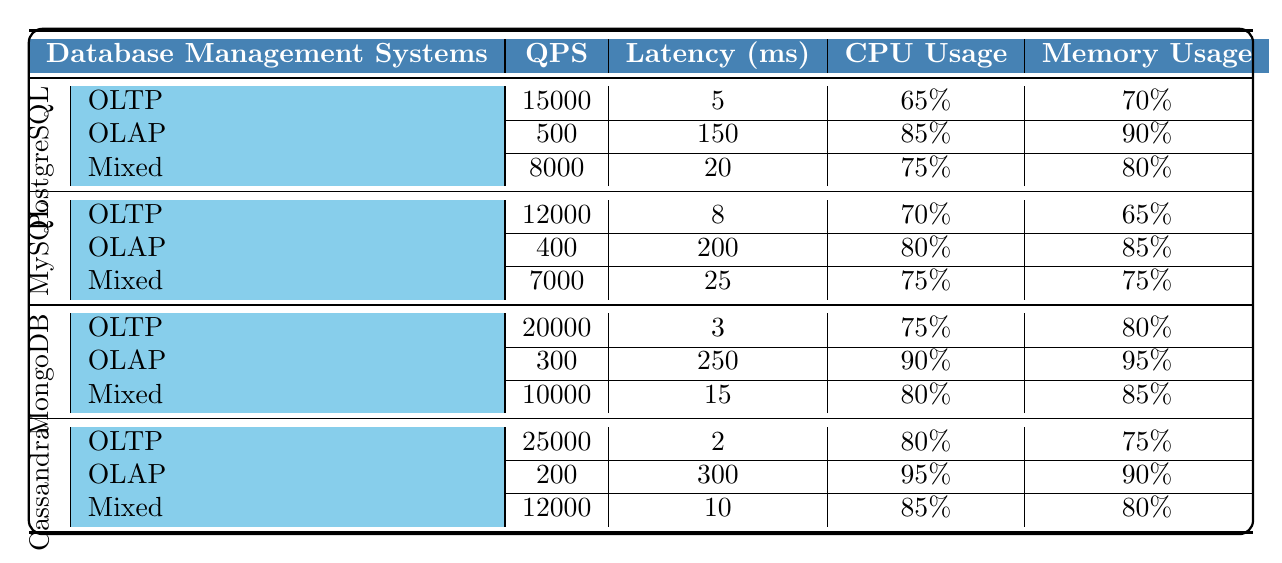What is the QPS for PostgreSQL in OLTP workload? In the table, locate the row for PostgreSQL and then find the OLTP workload. The QPS value for this workload is listed as 15000.
Answer: 15000 Which database system has the lowest latency for OLTP workloads? Review the OLTP latency values for all database systems. PostgreSQL has 5 ms, MySQL 8 ms, MongoDB 3 ms, and Cassandra 2 ms. The lowest value is 2 ms, which belongs to Cassandra.
Answer: Cassandra What is the average CPU usage across all database systems for the Mixed workload? Identify the CPU usage for the Mixed workload: PostgreSQL (75%), MySQL (75%), MongoDB (80%), and Cassandra (85%). Sum these values: 75 + 75 + 80 + 85 = 315. There are 4 systems, so the average is 315 / 4 = 78.75%.
Answer: 78.75% Is it true that MongoDB has a higher QPS than PostgreSQL for both OLAP and Mixed workloads? Compare the QPS values for MongoDB and PostgreSQL in OLAP and Mixed. In OLAP, PostgreSQL has 500 QPS while MongoDB has 300, showing PostgreSQL has a higher value. In Mixed, PostgreSQL has 8000 and MongoDB has 10000, indicating MongoDB is higher here. Since the first part is false, the overall statement is false.
Answer: No What is the difference in latency between OLTP and OLAP workloads for MySQL? For MySQL, look at the latency values for OLTP (8 ms) and OLAP (200 ms). Calculate the difference: 200 - 8 = 192 ms.
Answer: 192 Which database system uses the most memory for OLAP workloads? Check the memory usage for OLAP workloads in the table: PostgreSQL (90%), MySQL (85%), MongoDB (95%), Cassandra (90%). MongoDB shows the highest at 95%.
Answer: MongoDB What is the total QPS for all database systems under Mixed workloads? Find the QPS values for Mixed workloads: PostgreSQL (8000), MySQL (7000), MongoDB (10000), and Cassandra (12000). Add them: 8000 + 7000 + 10000 + 12000 = 37000.
Answer: 37000 Which workload type has the highest QPS in Cassandra? Look at the QPS values specifically for Cassandra: OLTP (25000), OLAP (200), Mixed (12000). The OLTP workload at 25000 has the highest QPS.
Answer: OLTP How does the CPU usage of MongoDB's OLAP workload compare to PostgreSQL's OLTP workload? Check the CPU usage: MongoDB OLAP is 90%, and PostgreSQL OLTP is 65%. Compare them directly to see that 90% is higher than 65%.
Answer: Higher What is the total memory usage for all database systems under OLTP workloads? Identify memory usage for OLTP across systems: PostgreSQL (70%), MySQL (65%), MongoDB (80%), and Cassandra (75%). Add these percentages: 70 + 65 + 80 + 75 = 290%.
Answer: 290% 